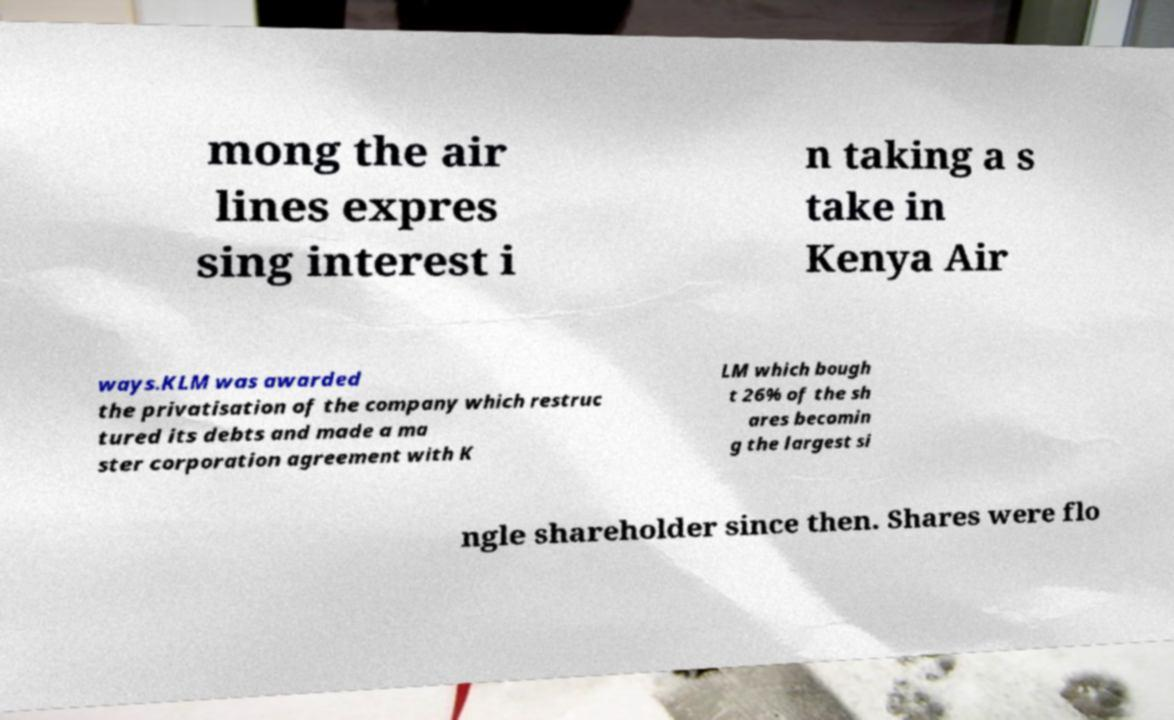Could you extract and type out the text from this image? mong the air lines expres sing interest i n taking a s take in Kenya Air ways.KLM was awarded the privatisation of the company which restruc tured its debts and made a ma ster corporation agreement with K LM which bough t 26% of the sh ares becomin g the largest si ngle shareholder since then. Shares were flo 